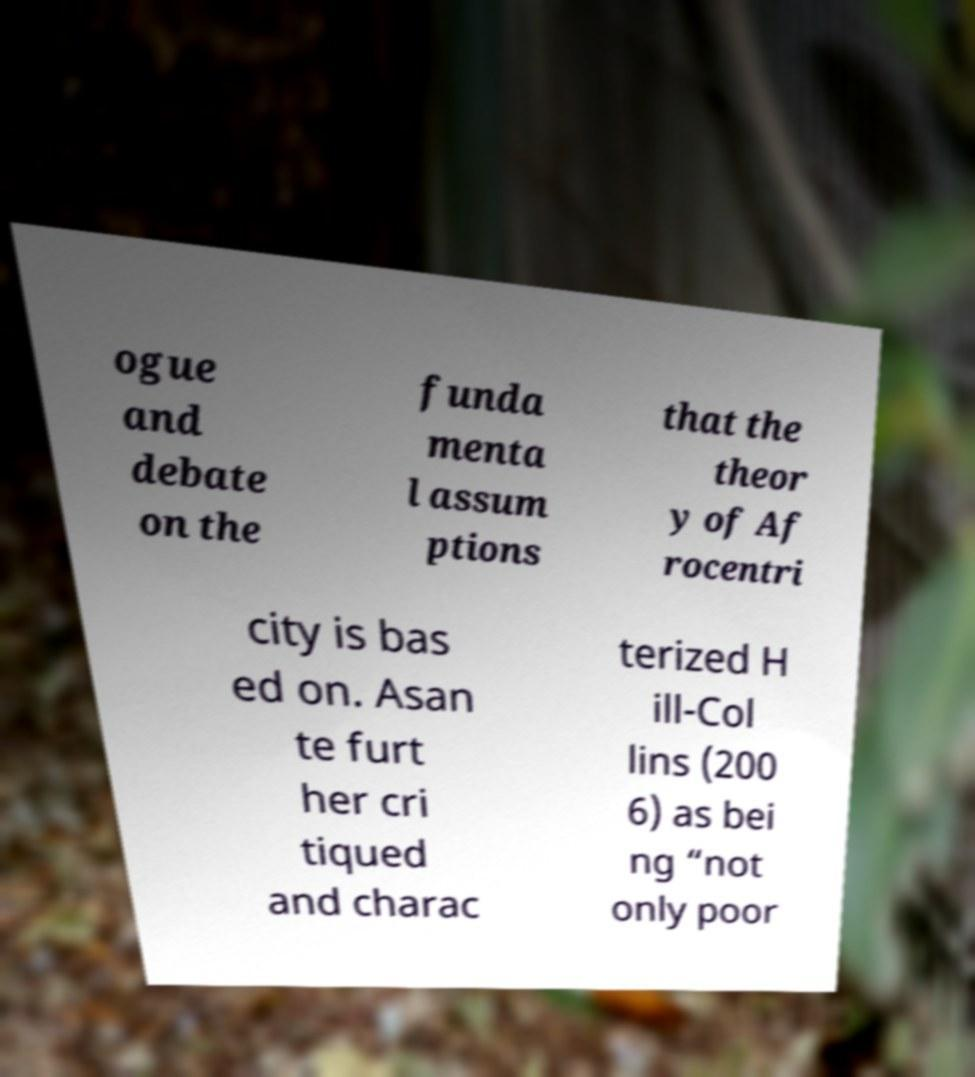Please read and relay the text visible in this image. What does it say? ogue and debate on the funda menta l assum ptions that the theor y of Af rocentri city is bas ed on. Asan te furt her cri tiqued and charac terized H ill-Col lins (200 6) as bei ng “not only poor 